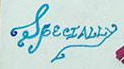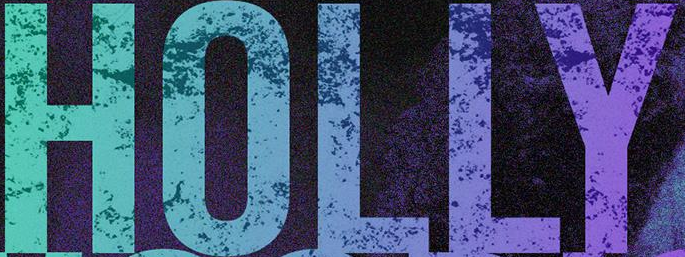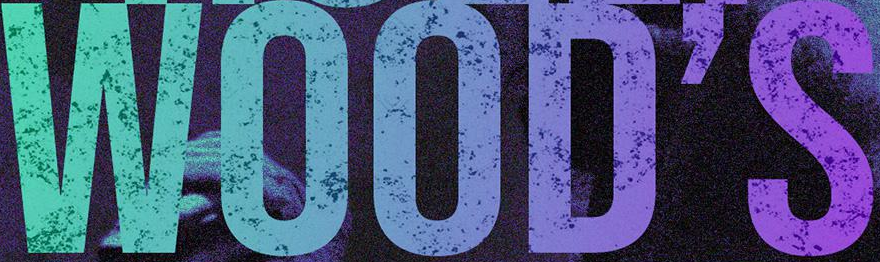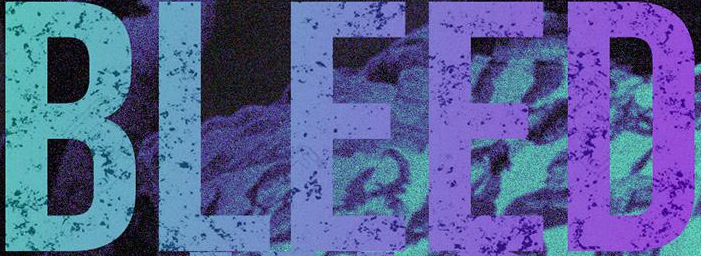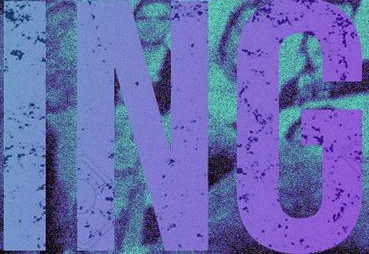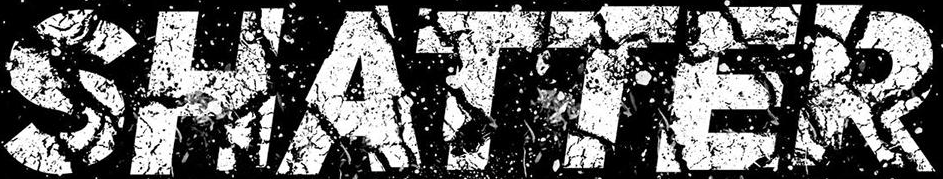Identify the words shown in these images in order, separated by a semicolon. SpecIALLy; HOLLY; WOOD'S; BLEED; ING; SHATTER 